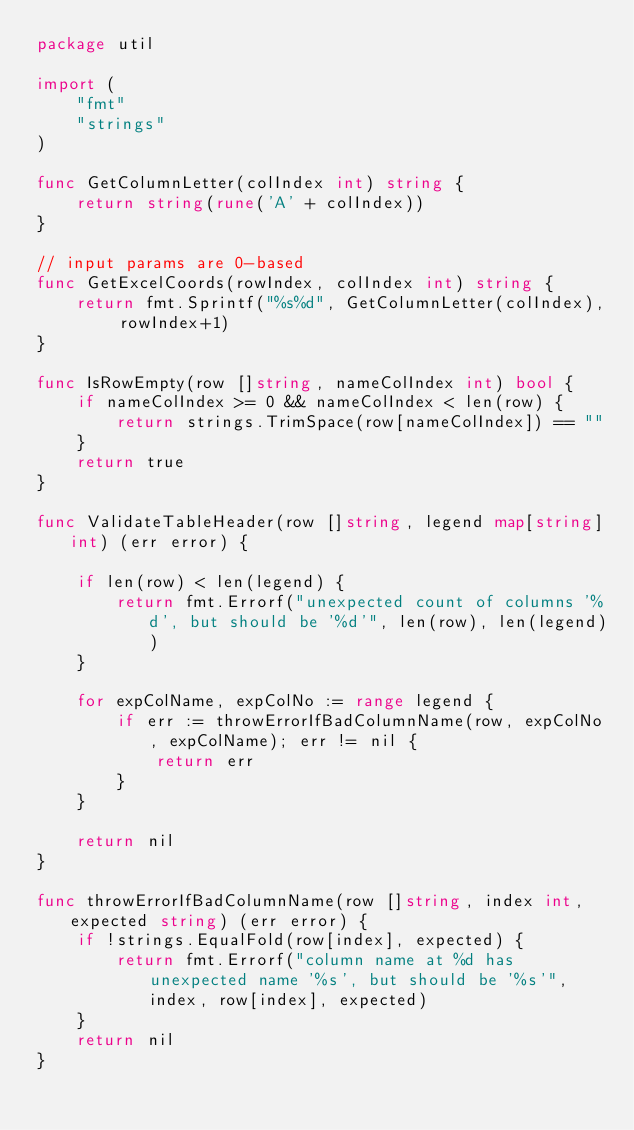<code> <loc_0><loc_0><loc_500><loc_500><_Go_>package util

import (
	"fmt"
	"strings"
)

func GetColumnLetter(colIndex int) string {
	return string(rune('A' + colIndex))
}

// input params are 0-based
func GetExcelCoords(rowIndex, colIndex int) string {
	return fmt.Sprintf("%s%d", GetColumnLetter(colIndex), rowIndex+1)
}

func IsRowEmpty(row []string, nameColIndex int) bool {
	if nameColIndex >= 0 && nameColIndex < len(row) {
		return strings.TrimSpace(row[nameColIndex]) == ""
	}
	return true
}

func ValidateTableHeader(row []string, legend map[string]int) (err error) {

	if len(row) < len(legend) {
		return fmt.Errorf("unexpected count of columns '%d', but should be '%d'", len(row), len(legend))
	}

	for expColName, expColNo := range legend {
		if err := throwErrorIfBadColumnName(row, expColNo, expColName); err != nil {
			return err
		}
	}

	return nil
}

func throwErrorIfBadColumnName(row []string, index int, expected string) (err error) {
	if !strings.EqualFold(row[index], expected) {
		return fmt.Errorf("column name at %d has unexpected name '%s', but should be '%s'", index, row[index], expected)
	}
	return nil
}
</code> 